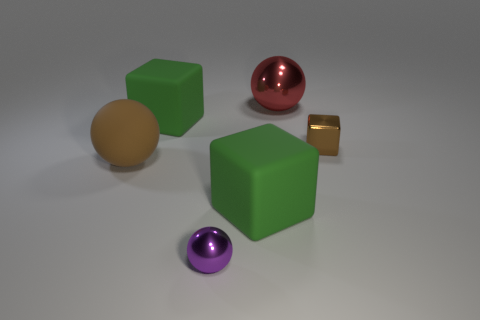What number of other things are there of the same color as the small metal block?
Ensure brevity in your answer.  1. There is a ball left of the big green matte cube behind the block on the right side of the large red object; what is its material?
Give a very brief answer. Rubber. What material is the brown thing that is right of the block on the left side of the purple ball?
Make the answer very short. Metal. Is the number of small brown metal cubes that are behind the brown cube less than the number of red metallic objects?
Keep it short and to the point. Yes. There is a brown thing to the left of the tiny metal sphere; what is its shape?
Ensure brevity in your answer.  Sphere. Does the purple object have the same size as the cube behind the tiny brown cube?
Offer a terse response. No. Is there a large green cube that has the same material as the big brown ball?
Give a very brief answer. Yes. How many cylinders are either big red things or purple objects?
Make the answer very short. 0. There is a large object in front of the big brown matte sphere; are there any things to the left of it?
Give a very brief answer. Yes. Are there fewer tiny purple spheres than metallic things?
Ensure brevity in your answer.  Yes. 